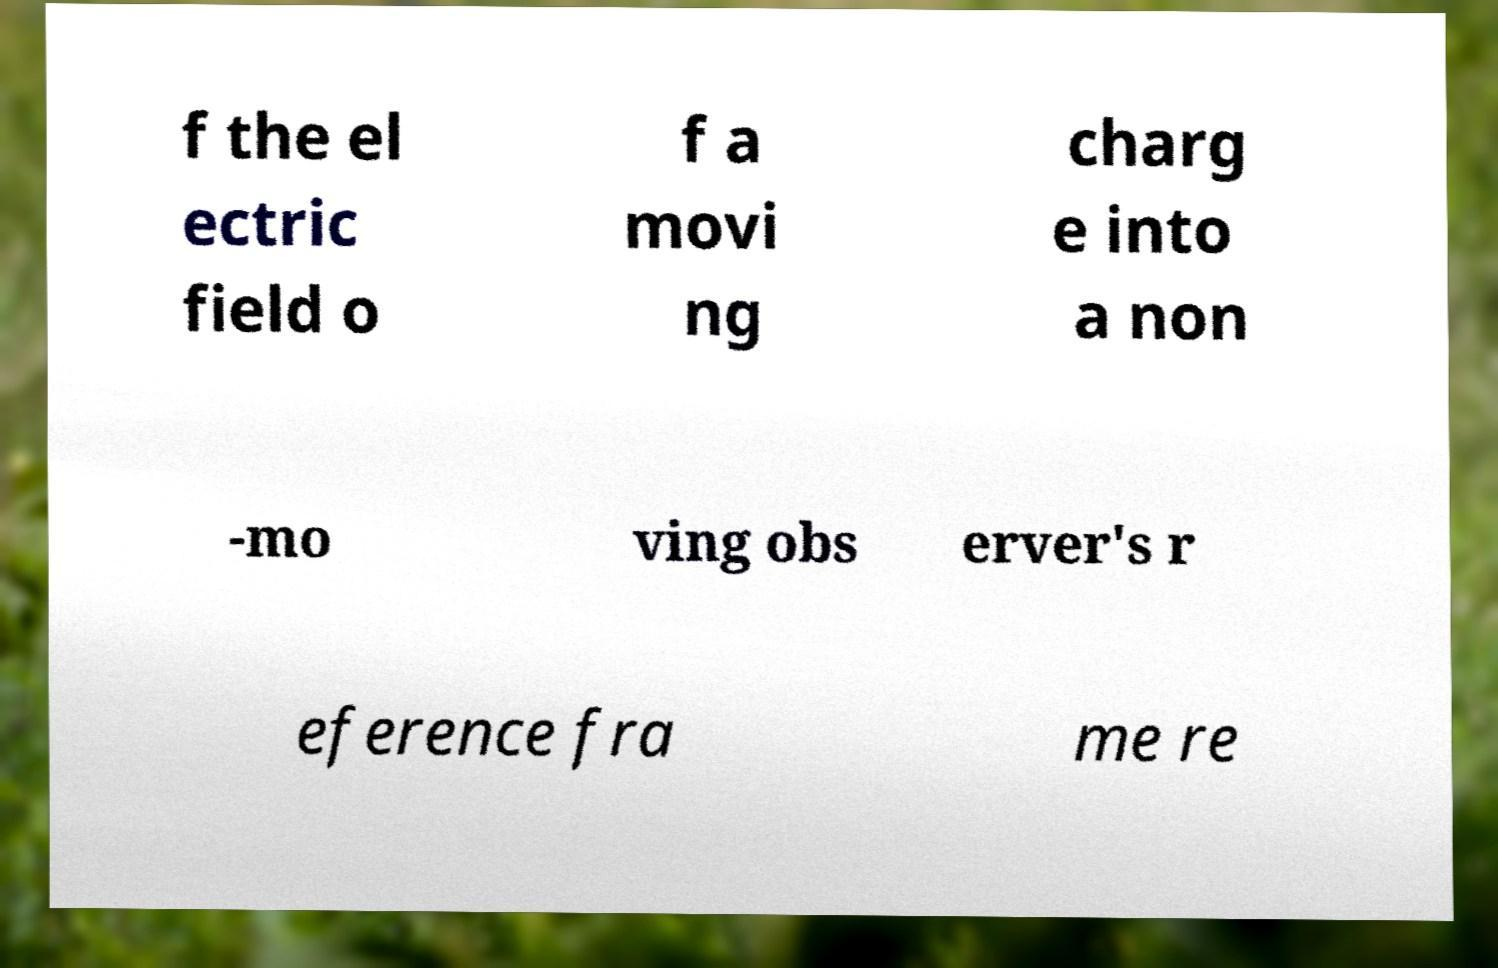There's text embedded in this image that I need extracted. Can you transcribe it verbatim? f the el ectric field o f a movi ng charg e into a non -mo ving obs erver's r eference fra me re 